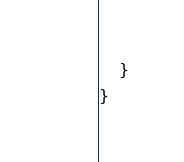Convert code to text. <code><loc_0><loc_0><loc_500><loc_500><_Java_>    }
}
</code> 